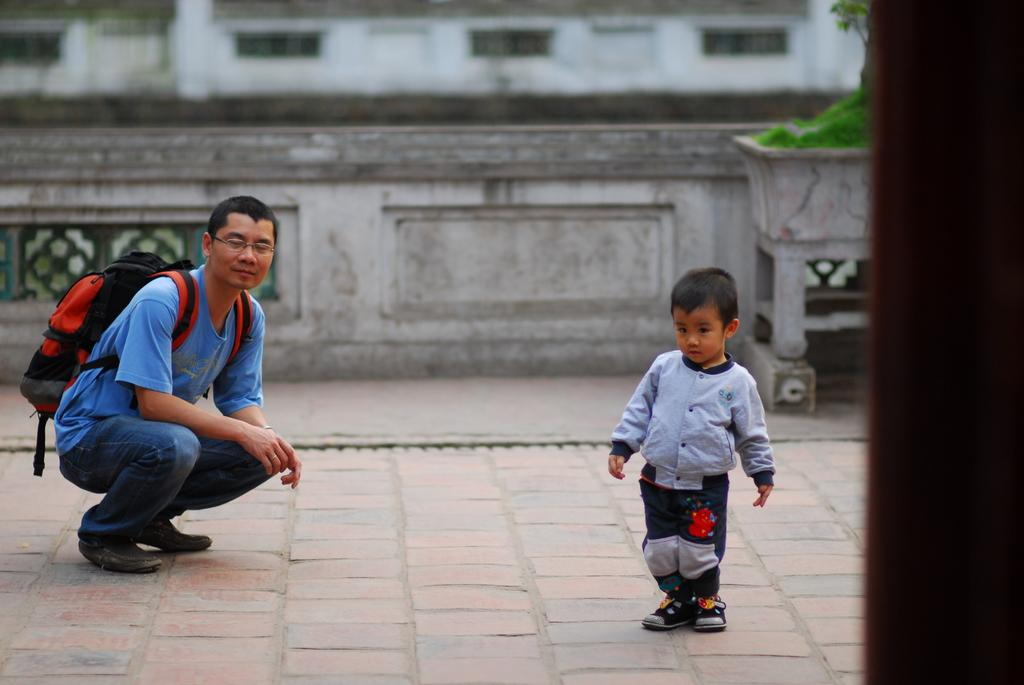Who can be seen in the picture? There is a man and a boy in the picture. What is the man wearing in the image? The man is wearing a backpack in the image. What can be seen on the right side of the image? There is a plant in a pot on the right side of the image. What is visible in the background of the image? There is a building in the background of the image. What type of stitch is being used to sew the cave in the image? There is no cave present in the image, and therefore, no stitching can be observed. 